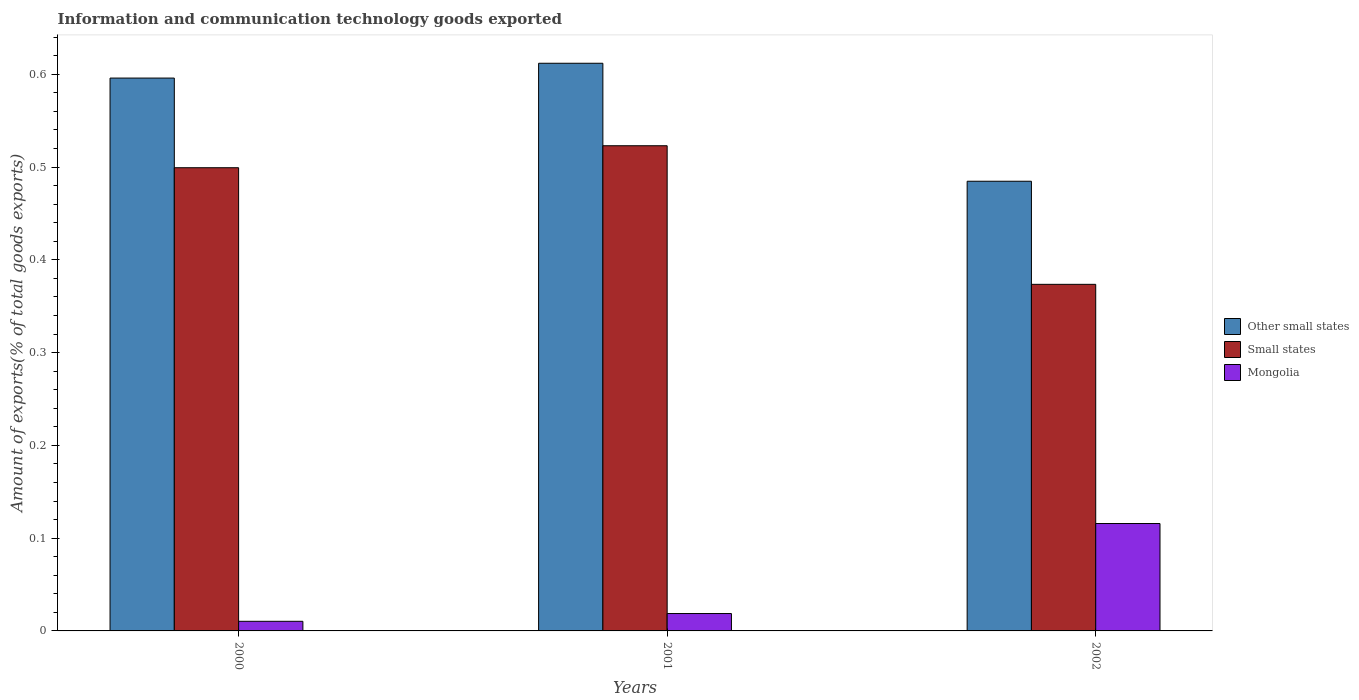How many different coloured bars are there?
Give a very brief answer. 3. Are the number of bars per tick equal to the number of legend labels?
Make the answer very short. Yes. Are the number of bars on each tick of the X-axis equal?
Provide a short and direct response. Yes. What is the amount of goods exported in Small states in 2000?
Keep it short and to the point. 0.5. Across all years, what is the maximum amount of goods exported in Mongolia?
Provide a succinct answer. 0.12. Across all years, what is the minimum amount of goods exported in Other small states?
Make the answer very short. 0.48. In which year was the amount of goods exported in Small states maximum?
Give a very brief answer. 2001. What is the total amount of goods exported in Small states in the graph?
Make the answer very short. 1.4. What is the difference between the amount of goods exported in Other small states in 2000 and that in 2001?
Make the answer very short. -0.02. What is the difference between the amount of goods exported in Other small states in 2000 and the amount of goods exported in Small states in 2002?
Provide a short and direct response. 0.22. What is the average amount of goods exported in Mongolia per year?
Provide a short and direct response. 0.05. In the year 2002, what is the difference between the amount of goods exported in Other small states and amount of goods exported in Small states?
Your response must be concise. 0.11. What is the ratio of the amount of goods exported in Other small states in 2000 to that in 2001?
Your response must be concise. 0.97. Is the amount of goods exported in Other small states in 2000 less than that in 2002?
Make the answer very short. No. What is the difference between the highest and the second highest amount of goods exported in Other small states?
Your response must be concise. 0.02. What is the difference between the highest and the lowest amount of goods exported in Small states?
Your answer should be very brief. 0.15. Is the sum of the amount of goods exported in Mongolia in 2000 and 2001 greater than the maximum amount of goods exported in Other small states across all years?
Offer a very short reply. No. What does the 3rd bar from the left in 2002 represents?
Give a very brief answer. Mongolia. What does the 3rd bar from the right in 2001 represents?
Provide a succinct answer. Other small states. Is it the case that in every year, the sum of the amount of goods exported in Mongolia and amount of goods exported in Other small states is greater than the amount of goods exported in Small states?
Your response must be concise. Yes. How many years are there in the graph?
Your response must be concise. 3. Does the graph contain grids?
Offer a very short reply. No. How many legend labels are there?
Make the answer very short. 3. How are the legend labels stacked?
Ensure brevity in your answer.  Vertical. What is the title of the graph?
Keep it short and to the point. Information and communication technology goods exported. What is the label or title of the X-axis?
Your answer should be very brief. Years. What is the label or title of the Y-axis?
Offer a terse response. Amount of exports(% of total goods exports). What is the Amount of exports(% of total goods exports) in Other small states in 2000?
Offer a terse response. 0.6. What is the Amount of exports(% of total goods exports) in Small states in 2000?
Ensure brevity in your answer.  0.5. What is the Amount of exports(% of total goods exports) in Mongolia in 2000?
Keep it short and to the point. 0.01. What is the Amount of exports(% of total goods exports) of Other small states in 2001?
Ensure brevity in your answer.  0.61. What is the Amount of exports(% of total goods exports) of Small states in 2001?
Ensure brevity in your answer.  0.52. What is the Amount of exports(% of total goods exports) of Mongolia in 2001?
Give a very brief answer. 0.02. What is the Amount of exports(% of total goods exports) in Other small states in 2002?
Offer a terse response. 0.48. What is the Amount of exports(% of total goods exports) in Small states in 2002?
Make the answer very short. 0.37. What is the Amount of exports(% of total goods exports) in Mongolia in 2002?
Offer a very short reply. 0.12. Across all years, what is the maximum Amount of exports(% of total goods exports) of Other small states?
Keep it short and to the point. 0.61. Across all years, what is the maximum Amount of exports(% of total goods exports) in Small states?
Keep it short and to the point. 0.52. Across all years, what is the maximum Amount of exports(% of total goods exports) in Mongolia?
Make the answer very short. 0.12. Across all years, what is the minimum Amount of exports(% of total goods exports) of Other small states?
Offer a terse response. 0.48. Across all years, what is the minimum Amount of exports(% of total goods exports) of Small states?
Your answer should be compact. 0.37. Across all years, what is the minimum Amount of exports(% of total goods exports) in Mongolia?
Offer a very short reply. 0.01. What is the total Amount of exports(% of total goods exports) in Other small states in the graph?
Make the answer very short. 1.69. What is the total Amount of exports(% of total goods exports) in Small states in the graph?
Give a very brief answer. 1.4. What is the total Amount of exports(% of total goods exports) in Mongolia in the graph?
Give a very brief answer. 0.14. What is the difference between the Amount of exports(% of total goods exports) of Other small states in 2000 and that in 2001?
Offer a terse response. -0.02. What is the difference between the Amount of exports(% of total goods exports) of Small states in 2000 and that in 2001?
Your response must be concise. -0.02. What is the difference between the Amount of exports(% of total goods exports) in Mongolia in 2000 and that in 2001?
Your answer should be very brief. -0.01. What is the difference between the Amount of exports(% of total goods exports) of Other small states in 2000 and that in 2002?
Your answer should be compact. 0.11. What is the difference between the Amount of exports(% of total goods exports) of Small states in 2000 and that in 2002?
Give a very brief answer. 0.13. What is the difference between the Amount of exports(% of total goods exports) in Mongolia in 2000 and that in 2002?
Your answer should be compact. -0.11. What is the difference between the Amount of exports(% of total goods exports) in Other small states in 2001 and that in 2002?
Keep it short and to the point. 0.13. What is the difference between the Amount of exports(% of total goods exports) in Small states in 2001 and that in 2002?
Your response must be concise. 0.15. What is the difference between the Amount of exports(% of total goods exports) in Mongolia in 2001 and that in 2002?
Give a very brief answer. -0.1. What is the difference between the Amount of exports(% of total goods exports) in Other small states in 2000 and the Amount of exports(% of total goods exports) in Small states in 2001?
Keep it short and to the point. 0.07. What is the difference between the Amount of exports(% of total goods exports) in Other small states in 2000 and the Amount of exports(% of total goods exports) in Mongolia in 2001?
Give a very brief answer. 0.58. What is the difference between the Amount of exports(% of total goods exports) in Small states in 2000 and the Amount of exports(% of total goods exports) in Mongolia in 2001?
Ensure brevity in your answer.  0.48. What is the difference between the Amount of exports(% of total goods exports) in Other small states in 2000 and the Amount of exports(% of total goods exports) in Small states in 2002?
Keep it short and to the point. 0.22. What is the difference between the Amount of exports(% of total goods exports) of Other small states in 2000 and the Amount of exports(% of total goods exports) of Mongolia in 2002?
Provide a short and direct response. 0.48. What is the difference between the Amount of exports(% of total goods exports) of Small states in 2000 and the Amount of exports(% of total goods exports) of Mongolia in 2002?
Give a very brief answer. 0.38. What is the difference between the Amount of exports(% of total goods exports) of Other small states in 2001 and the Amount of exports(% of total goods exports) of Small states in 2002?
Offer a very short reply. 0.24. What is the difference between the Amount of exports(% of total goods exports) in Other small states in 2001 and the Amount of exports(% of total goods exports) in Mongolia in 2002?
Your answer should be very brief. 0.5. What is the difference between the Amount of exports(% of total goods exports) of Small states in 2001 and the Amount of exports(% of total goods exports) of Mongolia in 2002?
Keep it short and to the point. 0.41. What is the average Amount of exports(% of total goods exports) in Other small states per year?
Provide a short and direct response. 0.56. What is the average Amount of exports(% of total goods exports) in Small states per year?
Provide a short and direct response. 0.47. What is the average Amount of exports(% of total goods exports) of Mongolia per year?
Offer a terse response. 0.05. In the year 2000, what is the difference between the Amount of exports(% of total goods exports) in Other small states and Amount of exports(% of total goods exports) in Small states?
Your response must be concise. 0.1. In the year 2000, what is the difference between the Amount of exports(% of total goods exports) of Other small states and Amount of exports(% of total goods exports) of Mongolia?
Offer a terse response. 0.59. In the year 2000, what is the difference between the Amount of exports(% of total goods exports) in Small states and Amount of exports(% of total goods exports) in Mongolia?
Offer a terse response. 0.49. In the year 2001, what is the difference between the Amount of exports(% of total goods exports) in Other small states and Amount of exports(% of total goods exports) in Small states?
Provide a short and direct response. 0.09. In the year 2001, what is the difference between the Amount of exports(% of total goods exports) in Other small states and Amount of exports(% of total goods exports) in Mongolia?
Offer a terse response. 0.59. In the year 2001, what is the difference between the Amount of exports(% of total goods exports) of Small states and Amount of exports(% of total goods exports) of Mongolia?
Your answer should be very brief. 0.5. In the year 2002, what is the difference between the Amount of exports(% of total goods exports) in Other small states and Amount of exports(% of total goods exports) in Mongolia?
Make the answer very short. 0.37. In the year 2002, what is the difference between the Amount of exports(% of total goods exports) in Small states and Amount of exports(% of total goods exports) in Mongolia?
Provide a succinct answer. 0.26. What is the ratio of the Amount of exports(% of total goods exports) in Other small states in 2000 to that in 2001?
Offer a very short reply. 0.97. What is the ratio of the Amount of exports(% of total goods exports) of Small states in 2000 to that in 2001?
Give a very brief answer. 0.95. What is the ratio of the Amount of exports(% of total goods exports) in Mongolia in 2000 to that in 2001?
Your answer should be very brief. 0.55. What is the ratio of the Amount of exports(% of total goods exports) in Other small states in 2000 to that in 2002?
Offer a very short reply. 1.23. What is the ratio of the Amount of exports(% of total goods exports) of Small states in 2000 to that in 2002?
Offer a very short reply. 1.34. What is the ratio of the Amount of exports(% of total goods exports) of Mongolia in 2000 to that in 2002?
Make the answer very short. 0.09. What is the ratio of the Amount of exports(% of total goods exports) of Other small states in 2001 to that in 2002?
Your answer should be very brief. 1.26. What is the ratio of the Amount of exports(% of total goods exports) of Small states in 2001 to that in 2002?
Give a very brief answer. 1.4. What is the ratio of the Amount of exports(% of total goods exports) of Mongolia in 2001 to that in 2002?
Your answer should be very brief. 0.16. What is the difference between the highest and the second highest Amount of exports(% of total goods exports) in Other small states?
Your response must be concise. 0.02. What is the difference between the highest and the second highest Amount of exports(% of total goods exports) in Small states?
Your answer should be compact. 0.02. What is the difference between the highest and the second highest Amount of exports(% of total goods exports) of Mongolia?
Make the answer very short. 0.1. What is the difference between the highest and the lowest Amount of exports(% of total goods exports) in Other small states?
Offer a terse response. 0.13. What is the difference between the highest and the lowest Amount of exports(% of total goods exports) in Small states?
Provide a succinct answer. 0.15. What is the difference between the highest and the lowest Amount of exports(% of total goods exports) in Mongolia?
Keep it short and to the point. 0.11. 